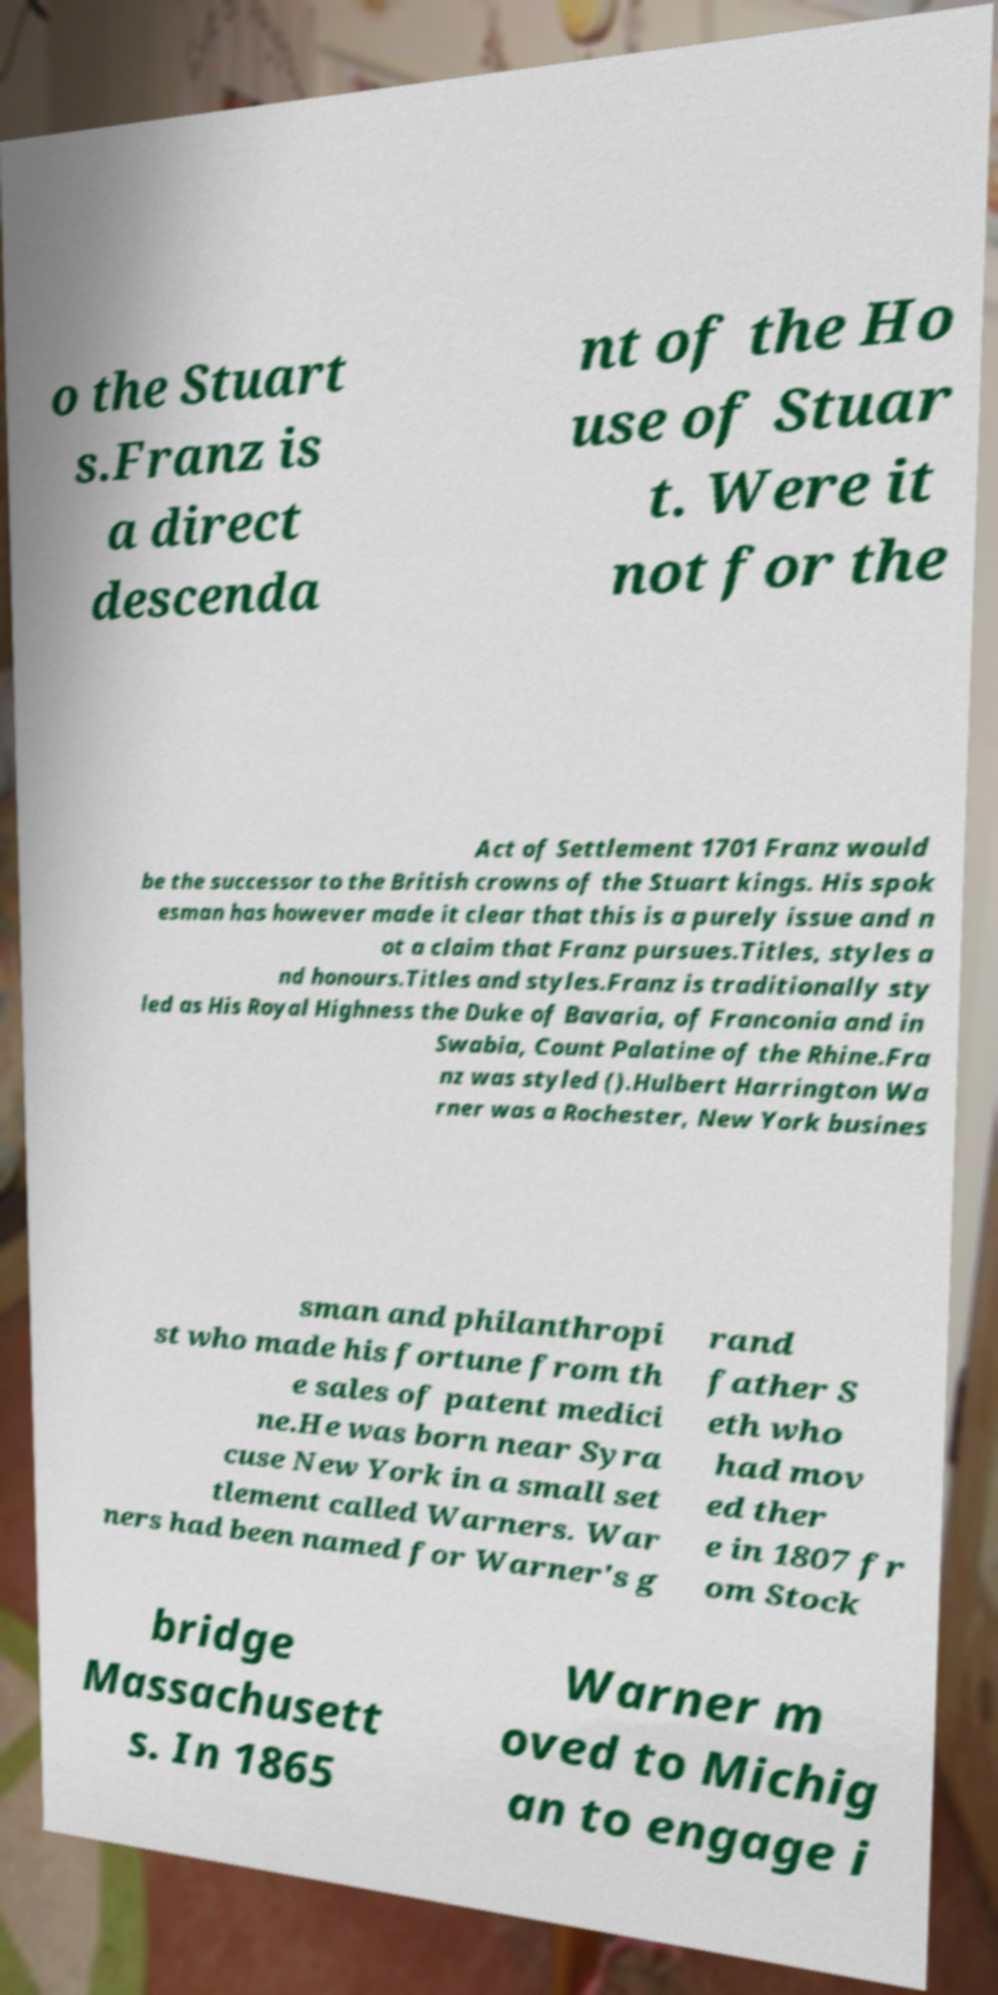I need the written content from this picture converted into text. Can you do that? o the Stuart s.Franz is a direct descenda nt of the Ho use of Stuar t. Were it not for the Act of Settlement 1701 Franz would be the successor to the British crowns of the Stuart kings. His spok esman has however made it clear that this is a purely issue and n ot a claim that Franz pursues.Titles, styles a nd honours.Titles and styles.Franz is traditionally sty led as His Royal Highness the Duke of Bavaria, of Franconia and in Swabia, Count Palatine of the Rhine.Fra nz was styled ().Hulbert Harrington Wa rner was a Rochester, New York busines sman and philanthropi st who made his fortune from th e sales of patent medici ne.He was born near Syra cuse New York in a small set tlement called Warners. War ners had been named for Warner's g rand father S eth who had mov ed ther e in 1807 fr om Stock bridge Massachusett s. In 1865 Warner m oved to Michig an to engage i 